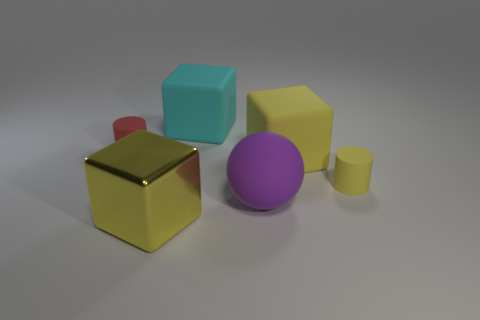How many other purple balls have the same material as the purple ball? 0 